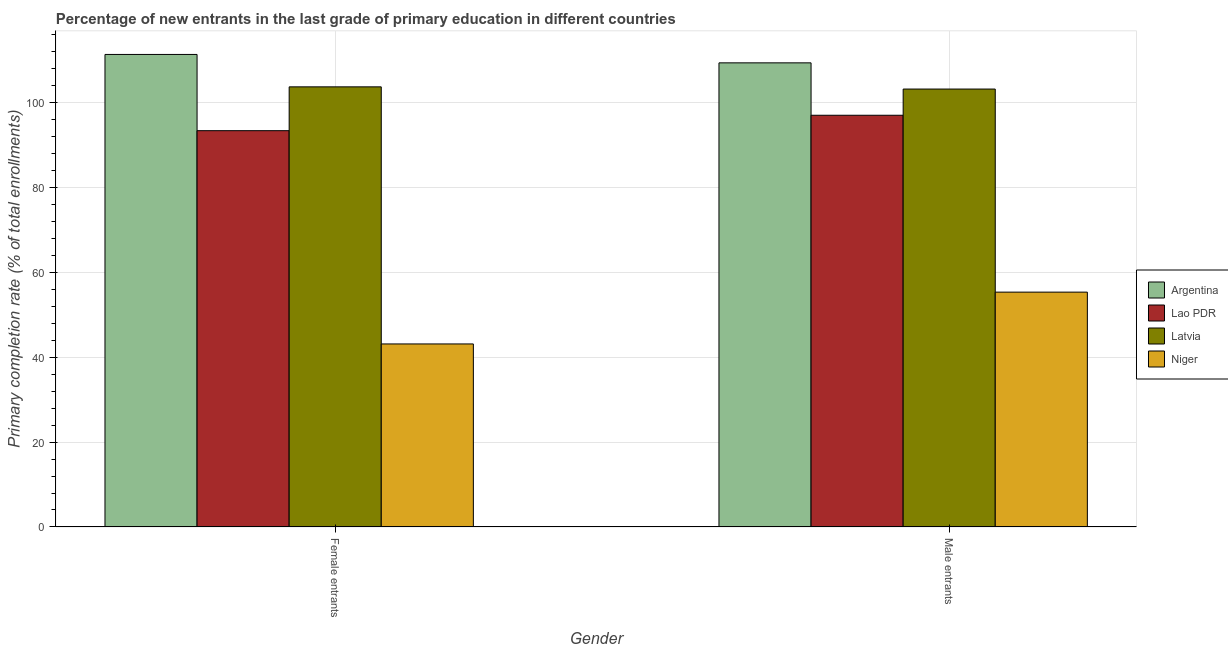Are the number of bars per tick equal to the number of legend labels?
Your response must be concise. Yes. How many bars are there on the 1st tick from the left?
Your response must be concise. 4. How many bars are there on the 1st tick from the right?
Give a very brief answer. 4. What is the label of the 1st group of bars from the left?
Make the answer very short. Female entrants. What is the primary completion rate of female entrants in Lao PDR?
Offer a very short reply. 93.27. Across all countries, what is the maximum primary completion rate of male entrants?
Your answer should be compact. 109.24. Across all countries, what is the minimum primary completion rate of male entrants?
Your answer should be compact. 55.28. In which country was the primary completion rate of male entrants maximum?
Your answer should be compact. Argentina. In which country was the primary completion rate of female entrants minimum?
Make the answer very short. Niger. What is the total primary completion rate of male entrants in the graph?
Provide a short and direct response. 364.49. What is the difference between the primary completion rate of female entrants in Argentina and that in Lao PDR?
Give a very brief answer. 17.94. What is the difference between the primary completion rate of male entrants in Niger and the primary completion rate of female entrants in Latvia?
Make the answer very short. -48.31. What is the average primary completion rate of female entrants per country?
Keep it short and to the point. 87.79. What is the difference between the primary completion rate of female entrants and primary completion rate of male entrants in Niger?
Ensure brevity in your answer.  -12.19. In how many countries, is the primary completion rate of male entrants greater than 32 %?
Keep it short and to the point. 4. What is the ratio of the primary completion rate of male entrants in Latvia to that in Argentina?
Your answer should be compact. 0.94. Is the primary completion rate of male entrants in Niger less than that in Argentina?
Your response must be concise. Yes. What does the 3rd bar from the left in Male entrants represents?
Make the answer very short. Latvia. How many bars are there?
Offer a terse response. 8. What is the difference between two consecutive major ticks on the Y-axis?
Ensure brevity in your answer.  20. Are the values on the major ticks of Y-axis written in scientific E-notation?
Provide a short and direct response. No. Does the graph contain any zero values?
Provide a short and direct response. No. Where does the legend appear in the graph?
Your answer should be very brief. Center right. How are the legend labels stacked?
Offer a terse response. Vertical. What is the title of the graph?
Ensure brevity in your answer.  Percentage of new entrants in the last grade of primary education in different countries. Does "Chad" appear as one of the legend labels in the graph?
Make the answer very short. No. What is the label or title of the X-axis?
Offer a terse response. Gender. What is the label or title of the Y-axis?
Offer a terse response. Primary completion rate (% of total enrollments). What is the Primary completion rate (% of total enrollments) of Argentina in Female entrants?
Your answer should be compact. 111.22. What is the Primary completion rate (% of total enrollments) of Lao PDR in Female entrants?
Keep it short and to the point. 93.27. What is the Primary completion rate (% of total enrollments) in Latvia in Female entrants?
Your answer should be compact. 103.59. What is the Primary completion rate (% of total enrollments) in Niger in Female entrants?
Provide a short and direct response. 43.08. What is the Primary completion rate (% of total enrollments) in Argentina in Male entrants?
Your answer should be compact. 109.24. What is the Primary completion rate (% of total enrollments) in Lao PDR in Male entrants?
Provide a short and direct response. 96.9. What is the Primary completion rate (% of total enrollments) of Latvia in Male entrants?
Give a very brief answer. 103.07. What is the Primary completion rate (% of total enrollments) of Niger in Male entrants?
Give a very brief answer. 55.28. Across all Gender, what is the maximum Primary completion rate (% of total enrollments) of Argentina?
Your answer should be compact. 111.22. Across all Gender, what is the maximum Primary completion rate (% of total enrollments) of Lao PDR?
Provide a short and direct response. 96.9. Across all Gender, what is the maximum Primary completion rate (% of total enrollments) of Latvia?
Your answer should be compact. 103.59. Across all Gender, what is the maximum Primary completion rate (% of total enrollments) of Niger?
Offer a very short reply. 55.28. Across all Gender, what is the minimum Primary completion rate (% of total enrollments) in Argentina?
Provide a short and direct response. 109.24. Across all Gender, what is the minimum Primary completion rate (% of total enrollments) in Lao PDR?
Give a very brief answer. 93.27. Across all Gender, what is the minimum Primary completion rate (% of total enrollments) in Latvia?
Ensure brevity in your answer.  103.07. Across all Gender, what is the minimum Primary completion rate (% of total enrollments) in Niger?
Ensure brevity in your answer.  43.08. What is the total Primary completion rate (% of total enrollments) of Argentina in the graph?
Make the answer very short. 220.45. What is the total Primary completion rate (% of total enrollments) in Lao PDR in the graph?
Your answer should be very brief. 190.18. What is the total Primary completion rate (% of total enrollments) in Latvia in the graph?
Provide a succinct answer. 206.66. What is the total Primary completion rate (% of total enrollments) of Niger in the graph?
Offer a very short reply. 98.36. What is the difference between the Primary completion rate (% of total enrollments) in Argentina in Female entrants and that in Male entrants?
Your answer should be very brief. 1.98. What is the difference between the Primary completion rate (% of total enrollments) in Lao PDR in Female entrants and that in Male entrants?
Make the answer very short. -3.63. What is the difference between the Primary completion rate (% of total enrollments) in Latvia in Female entrants and that in Male entrants?
Your answer should be compact. 0.52. What is the difference between the Primary completion rate (% of total enrollments) in Niger in Female entrants and that in Male entrants?
Give a very brief answer. -12.2. What is the difference between the Primary completion rate (% of total enrollments) in Argentina in Female entrants and the Primary completion rate (% of total enrollments) in Lao PDR in Male entrants?
Give a very brief answer. 14.31. What is the difference between the Primary completion rate (% of total enrollments) of Argentina in Female entrants and the Primary completion rate (% of total enrollments) of Latvia in Male entrants?
Make the answer very short. 8.14. What is the difference between the Primary completion rate (% of total enrollments) of Argentina in Female entrants and the Primary completion rate (% of total enrollments) of Niger in Male entrants?
Give a very brief answer. 55.94. What is the difference between the Primary completion rate (% of total enrollments) in Lao PDR in Female entrants and the Primary completion rate (% of total enrollments) in Latvia in Male entrants?
Your answer should be compact. -9.8. What is the difference between the Primary completion rate (% of total enrollments) of Lao PDR in Female entrants and the Primary completion rate (% of total enrollments) of Niger in Male entrants?
Ensure brevity in your answer.  38. What is the difference between the Primary completion rate (% of total enrollments) in Latvia in Female entrants and the Primary completion rate (% of total enrollments) in Niger in Male entrants?
Offer a very short reply. 48.31. What is the average Primary completion rate (% of total enrollments) of Argentina per Gender?
Your response must be concise. 110.23. What is the average Primary completion rate (% of total enrollments) of Lao PDR per Gender?
Your answer should be very brief. 95.09. What is the average Primary completion rate (% of total enrollments) in Latvia per Gender?
Give a very brief answer. 103.33. What is the average Primary completion rate (% of total enrollments) of Niger per Gender?
Offer a very short reply. 49.18. What is the difference between the Primary completion rate (% of total enrollments) of Argentina and Primary completion rate (% of total enrollments) of Lao PDR in Female entrants?
Ensure brevity in your answer.  17.94. What is the difference between the Primary completion rate (% of total enrollments) in Argentina and Primary completion rate (% of total enrollments) in Latvia in Female entrants?
Your response must be concise. 7.63. What is the difference between the Primary completion rate (% of total enrollments) in Argentina and Primary completion rate (% of total enrollments) in Niger in Female entrants?
Offer a very short reply. 68.14. What is the difference between the Primary completion rate (% of total enrollments) of Lao PDR and Primary completion rate (% of total enrollments) of Latvia in Female entrants?
Provide a short and direct response. -10.32. What is the difference between the Primary completion rate (% of total enrollments) of Lao PDR and Primary completion rate (% of total enrollments) of Niger in Female entrants?
Ensure brevity in your answer.  50.19. What is the difference between the Primary completion rate (% of total enrollments) in Latvia and Primary completion rate (% of total enrollments) in Niger in Female entrants?
Your response must be concise. 60.51. What is the difference between the Primary completion rate (% of total enrollments) in Argentina and Primary completion rate (% of total enrollments) in Lao PDR in Male entrants?
Your answer should be very brief. 12.33. What is the difference between the Primary completion rate (% of total enrollments) in Argentina and Primary completion rate (% of total enrollments) in Latvia in Male entrants?
Keep it short and to the point. 6.17. What is the difference between the Primary completion rate (% of total enrollments) of Argentina and Primary completion rate (% of total enrollments) of Niger in Male entrants?
Your response must be concise. 53.96. What is the difference between the Primary completion rate (% of total enrollments) in Lao PDR and Primary completion rate (% of total enrollments) in Latvia in Male entrants?
Provide a succinct answer. -6.17. What is the difference between the Primary completion rate (% of total enrollments) of Lao PDR and Primary completion rate (% of total enrollments) of Niger in Male entrants?
Your answer should be very brief. 41.63. What is the difference between the Primary completion rate (% of total enrollments) in Latvia and Primary completion rate (% of total enrollments) in Niger in Male entrants?
Make the answer very short. 47.8. What is the ratio of the Primary completion rate (% of total enrollments) in Argentina in Female entrants to that in Male entrants?
Offer a terse response. 1.02. What is the ratio of the Primary completion rate (% of total enrollments) in Lao PDR in Female entrants to that in Male entrants?
Ensure brevity in your answer.  0.96. What is the ratio of the Primary completion rate (% of total enrollments) in Niger in Female entrants to that in Male entrants?
Your response must be concise. 0.78. What is the difference between the highest and the second highest Primary completion rate (% of total enrollments) in Argentina?
Your answer should be compact. 1.98. What is the difference between the highest and the second highest Primary completion rate (% of total enrollments) of Lao PDR?
Your answer should be compact. 3.63. What is the difference between the highest and the second highest Primary completion rate (% of total enrollments) in Latvia?
Offer a terse response. 0.52. What is the difference between the highest and the second highest Primary completion rate (% of total enrollments) of Niger?
Your response must be concise. 12.2. What is the difference between the highest and the lowest Primary completion rate (% of total enrollments) in Argentina?
Provide a succinct answer. 1.98. What is the difference between the highest and the lowest Primary completion rate (% of total enrollments) of Lao PDR?
Give a very brief answer. 3.63. What is the difference between the highest and the lowest Primary completion rate (% of total enrollments) of Latvia?
Make the answer very short. 0.52. What is the difference between the highest and the lowest Primary completion rate (% of total enrollments) in Niger?
Provide a short and direct response. 12.2. 